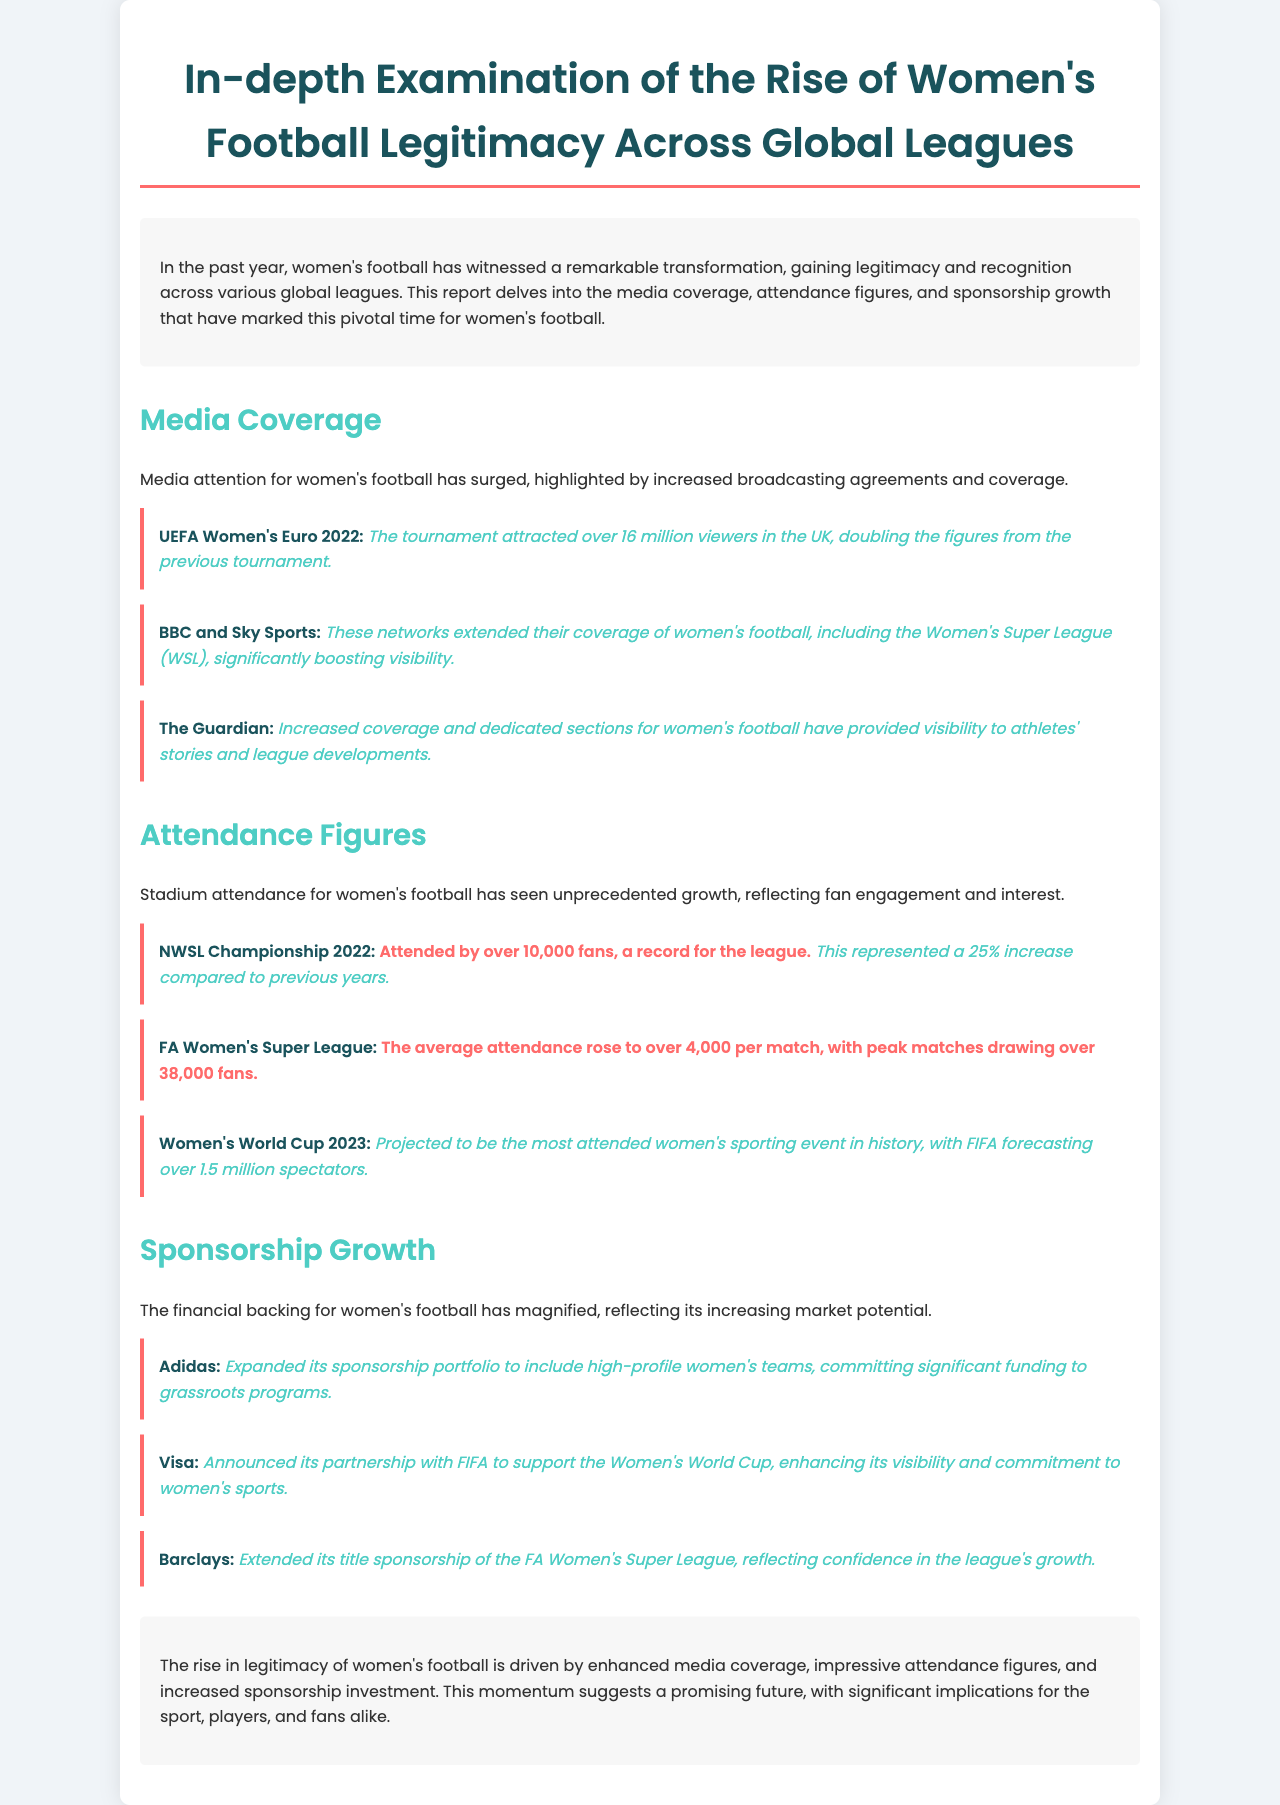What was the viewership for UEFA Women's Euro 2022 in the UK? The document states that over 16 million viewers in the UK watched the tournament, which is a significant increase.
Answer: over 16 million What is the average attendance per match in the FA Women's Super League? According to the report, the average attendance has risen to over 4,000 per match.
Answer: over 4,000 Which network extended its coverage of women's football significantly? The document highlights that BBC and Sky Sports have extended their coverage of women's football.
Answer: BBC and Sky Sports What was the attendance figure for the NWSL Championship 2022? The report mentions that the NWSL Championship 2022 was attended by over 10,000 fans, which is a record.
Answer: over 10,000 fans Which company announced its partnership with FIFA for the Women's World Cup? Visa is the company that announced its partnership with FIFA, as mentioned in the document.
Answer: Visa What increase in attendance percentage did the NWSL Championship experience compared to previous years? The document indicates that there was a 25% increase compared to previous years.
Answer: 25% What entity extended its title sponsorship of the FA Women's Super League? Barclays is the entity that extended its title sponsorship, reflecting confidence in the league's growth.
Answer: Barclays What is projected for the Women's World Cup 2023 regarding attendance? The report forecasts that it will be the most attended women's sporting event in history, with over 1.5 million spectators expected.
Answer: over 1.5 million spectators What has surged significantly in women's football over the past year? The document emphasizes that media attention for women's football has surged, marked by increased broadcasting agreements.
Answer: media attention 